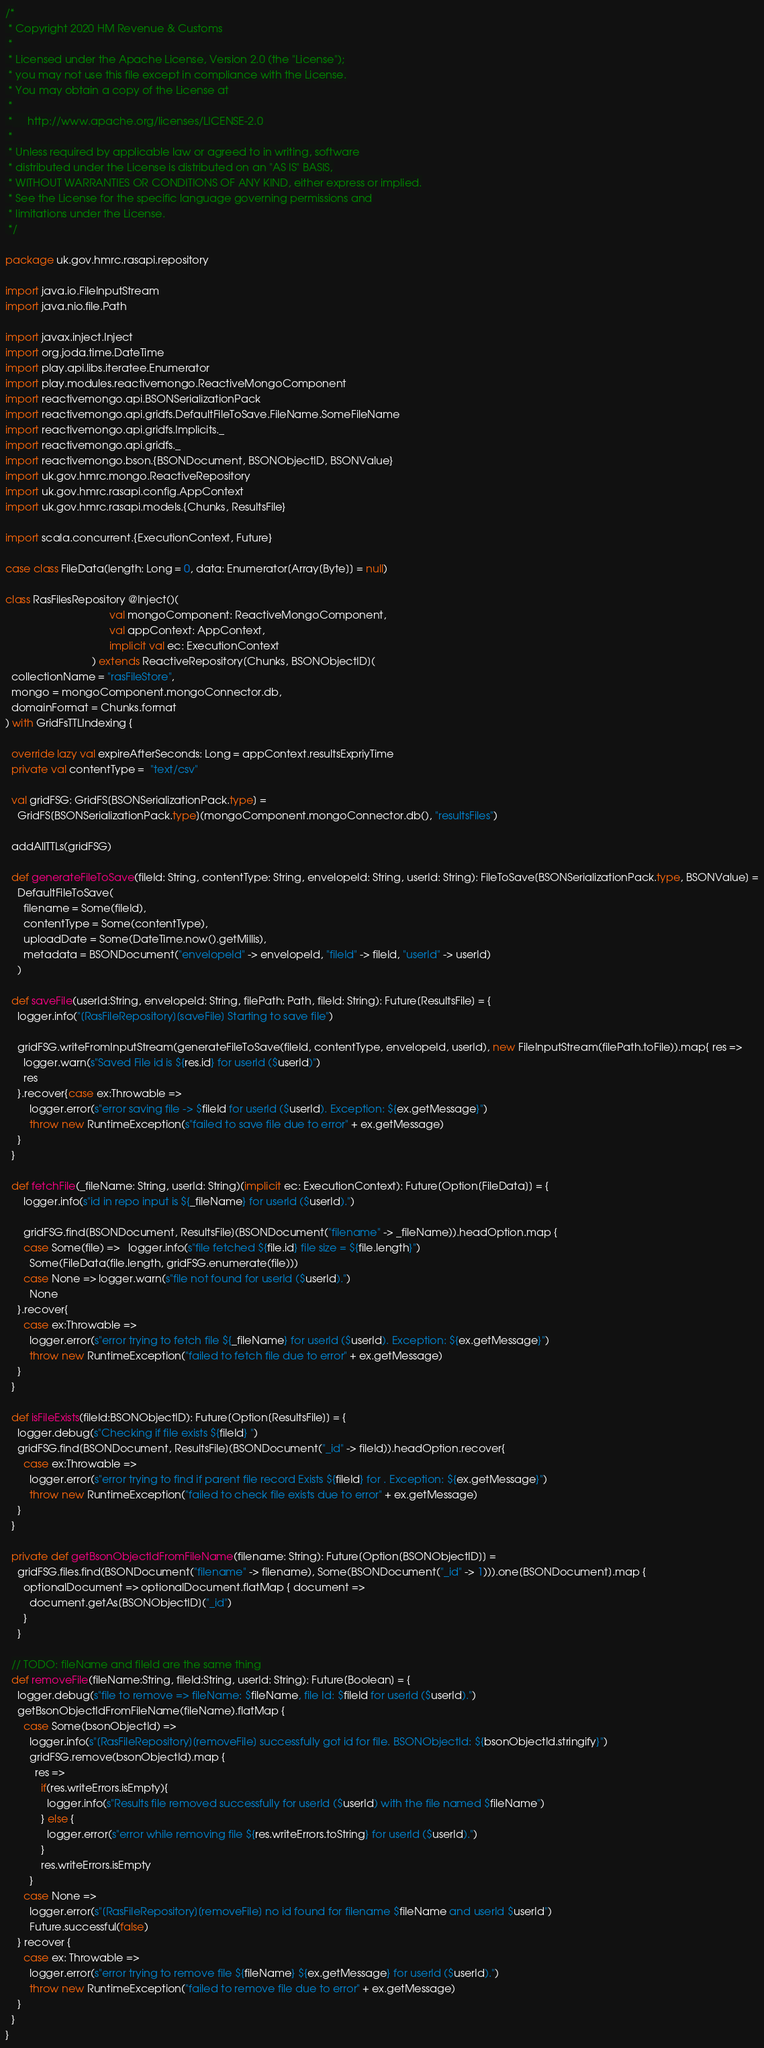Convert code to text. <code><loc_0><loc_0><loc_500><loc_500><_Scala_>/*
 * Copyright 2020 HM Revenue & Customs
 *
 * Licensed under the Apache License, Version 2.0 (the "License");
 * you may not use this file except in compliance with the License.
 * You may obtain a copy of the License at
 *
 *     http://www.apache.org/licenses/LICENSE-2.0
 *
 * Unless required by applicable law or agreed to in writing, software
 * distributed under the License is distributed on an "AS IS" BASIS,
 * WITHOUT WARRANTIES OR CONDITIONS OF ANY KIND, either express or implied.
 * See the License for the specific language governing permissions and
 * limitations under the License.
 */

package uk.gov.hmrc.rasapi.repository

import java.io.FileInputStream
import java.nio.file.Path

import javax.inject.Inject
import org.joda.time.DateTime
import play.api.libs.iteratee.Enumerator
import play.modules.reactivemongo.ReactiveMongoComponent
import reactivemongo.api.BSONSerializationPack
import reactivemongo.api.gridfs.DefaultFileToSave.FileName.SomeFileName
import reactivemongo.api.gridfs.Implicits._
import reactivemongo.api.gridfs._
import reactivemongo.bson.{BSONDocument, BSONObjectID, BSONValue}
import uk.gov.hmrc.mongo.ReactiveRepository
import uk.gov.hmrc.rasapi.config.AppContext
import uk.gov.hmrc.rasapi.models.{Chunks, ResultsFile}

import scala.concurrent.{ExecutionContext, Future}

case class FileData(length: Long = 0, data: Enumerator[Array[Byte]] = null)

class RasFilesRepository @Inject()(
                                   val mongoComponent: ReactiveMongoComponent,
                                   val appContext: AppContext,
                                   implicit val ec: ExecutionContext
                             ) extends ReactiveRepository[Chunks, BSONObjectID](
  collectionName = "rasFileStore",
  mongo = mongoComponent.mongoConnector.db,
  domainFormat = Chunks.format
) with GridFsTTLIndexing {

  override lazy val expireAfterSeconds: Long = appContext.resultsExpriyTime
  private val contentType =  "text/csv"

  val gridFSG: GridFS[BSONSerializationPack.type] =
    GridFS[BSONSerializationPack.type](mongoComponent.mongoConnector.db(), "resultsFiles")

  addAllTTLs(gridFSG)

  def generateFileToSave(fileId: String, contentType: String, envelopeId: String, userId: String): FileToSave[BSONSerializationPack.type, BSONValue] =
    DefaultFileToSave(
      filename = Some(fileId),
      contentType = Some(contentType),
      uploadDate = Some(DateTime.now().getMillis),
      metadata = BSONDocument("envelopeId" -> envelopeId, "fileId" -> fileId, "userId" -> userId)
    )

  def saveFile(userId:String, envelopeId: String, filePath: Path, fileId: String): Future[ResultsFile] = {
    logger.info("[RasFileRepository][saveFile] Starting to save file")

    gridFSG.writeFromInputStream(generateFileToSave(fileId, contentType, envelopeId, userId), new FileInputStream(filePath.toFile)).map{ res =>
      logger.warn(s"Saved File id is ${res.id} for userId ($userId)")
      res
    }.recover{case ex:Throwable =>
        logger.error(s"error saving file -> $fileId for userId ($userId). Exception: ${ex.getMessage}")
        throw new RuntimeException(s"failed to save file due to error" + ex.getMessage)
    }
  }

  def fetchFile(_fileName: String, userId: String)(implicit ec: ExecutionContext): Future[Option[FileData]] = {
      logger.info(s"id in repo input is ${_fileName} for userId ($userId).")

      gridFSG.find[BSONDocument, ResultsFile](BSONDocument("filename" -> _fileName)).headOption.map {
      case Some(file) =>   logger.info(s"file fetched ${file.id} file size = ${file.length}")
        Some(FileData(file.length, gridFSG.enumerate(file)))
      case None => logger.warn(s"file not found for userId ($userId).")
        None
    }.recover{
      case ex:Throwable =>
        logger.error(s"error trying to fetch file ${_fileName} for userId ($userId). Exception: ${ex.getMessage}")
        throw new RuntimeException("failed to fetch file due to error" + ex.getMessage)
    }
  }

  def isFileExists(fileId:BSONObjectID): Future[Option[ResultsFile]] = {
    logger.debug(s"Checking if file exists ${fileId} ")
    gridFSG.find[BSONDocument, ResultsFile](BSONDocument("_id" -> fileId)).headOption.recover{
      case ex:Throwable =>
        logger.error(s"error trying to find if parent file record Exists ${fileId} for . Exception: ${ex.getMessage}")
        throw new RuntimeException("failed to check file exists due to error" + ex.getMessage)
    }
  }

  private def getBsonObjectIdFromFileName(filename: String): Future[Option[BSONObjectID]] =
    gridFSG.files.find(BSONDocument("filename" -> filename), Some(BSONDocument("_id" -> 1))).one[BSONDocument].map {
      optionalDocument => optionalDocument.flatMap { document =>
        document.getAs[BSONObjectID]("_id")
      }
    }

  // TODO: fileName and fileId are the same thing
  def removeFile(fileName:String, fileId:String, userId: String): Future[Boolean] = {
    logger.debug(s"file to remove => fileName: $fileName, file Id: $fileId for userId ($userId).")
    getBsonObjectIdFromFileName(fileName).flatMap {
      case Some(bsonObjectId) =>
        logger.info(s"[RasFileRepository][removeFile] successfully got id for file. BSONObjectId: ${bsonObjectId.stringify}")
        gridFSG.remove(bsonObjectId).map {
          res =>
            if(res.writeErrors.isEmpty){
              logger.info(s"Results file removed successfully for userId ($userId) with the file named $fileName")
            } else {
              logger.error(s"error while removing file ${res.writeErrors.toString} for userId ($userId).")
            }
            res.writeErrors.isEmpty
        }
      case None =>
        logger.error(s"[RasFileRepository][removeFile] no id found for filename $fileName and userId $userId")
        Future.successful(false)
    } recover {
      case ex: Throwable =>
        logger.error(s"error trying to remove file ${fileName} ${ex.getMessage} for userId ($userId).")
        throw new RuntimeException("failed to remove file due to error" + ex.getMessage)
    }
  }
}
</code> 